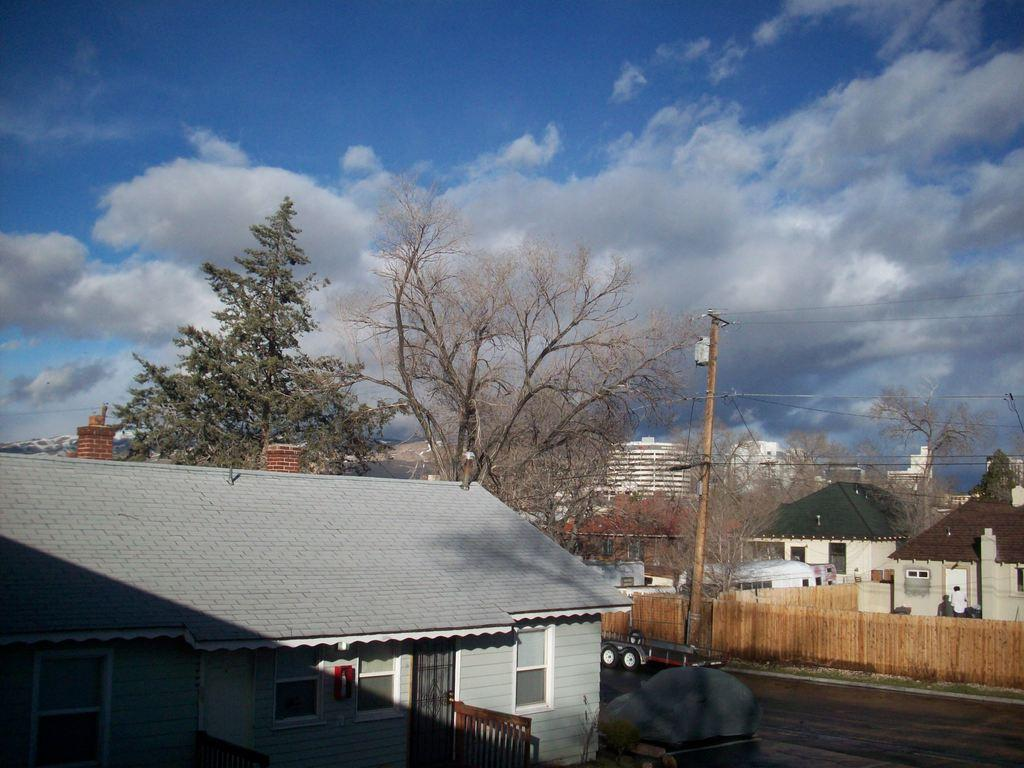What type of structures can be seen in the image? There are houses and buildings in the image. What natural elements are present in the image? There are trees in the image. What man-made structures can be seen in the image? There is a fence and a current pole with wires in the image. What mode of transportation can be seen in the image? There are vehicles on the road in the image. What part of the natural environment is visible in the image? The sky is visible in the background of the image. Where is the lift located in the image? There is no lift present in the image. What type of map can be seen in the image? There is no map present in the image. 